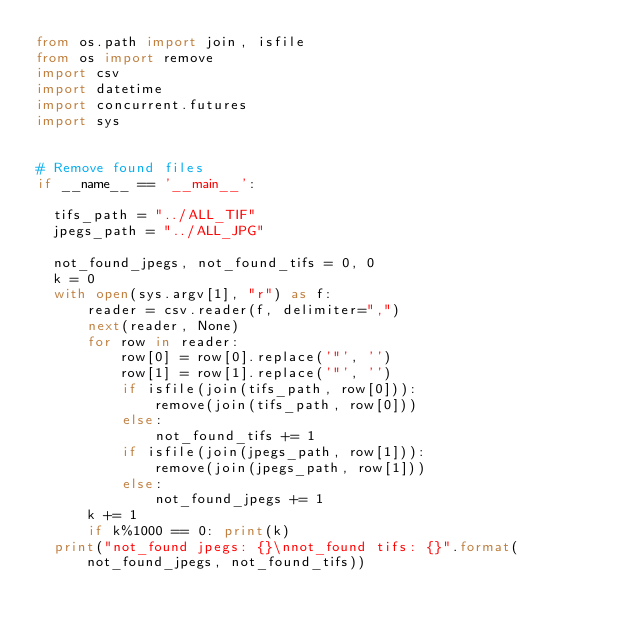<code> <loc_0><loc_0><loc_500><loc_500><_Python_>from os.path import join, isfile
from os import remove
import csv
import datetime
import concurrent.futures
import sys


# Remove found files
if __name__ == '__main__':

  tifs_path = "../ALL_TIF"
  jpegs_path = "../ALL_JPG"

  not_found_jpegs, not_found_tifs = 0, 0
  k = 0
  with open(sys.argv[1], "r") as f:
      reader = csv.reader(f, delimiter=",")
      next(reader, None)
      for row in reader:
          row[0] = row[0].replace('"', '')
          row[1] = row[1].replace('"', '')
          if isfile(join(tifs_path, row[0])):
              remove(join(tifs_path, row[0]))
          else:
              not_found_tifs += 1
          if isfile(join(jpegs_path, row[1])):
              remove(join(jpegs_path, row[1]))
          else:
              not_found_jpegs += 1
      k += 1
      if k%1000 == 0: print(k)
  print("not_found jpegs: {}\nnot_found tifs: {}".format(not_found_jpegs, not_found_tifs))</code> 